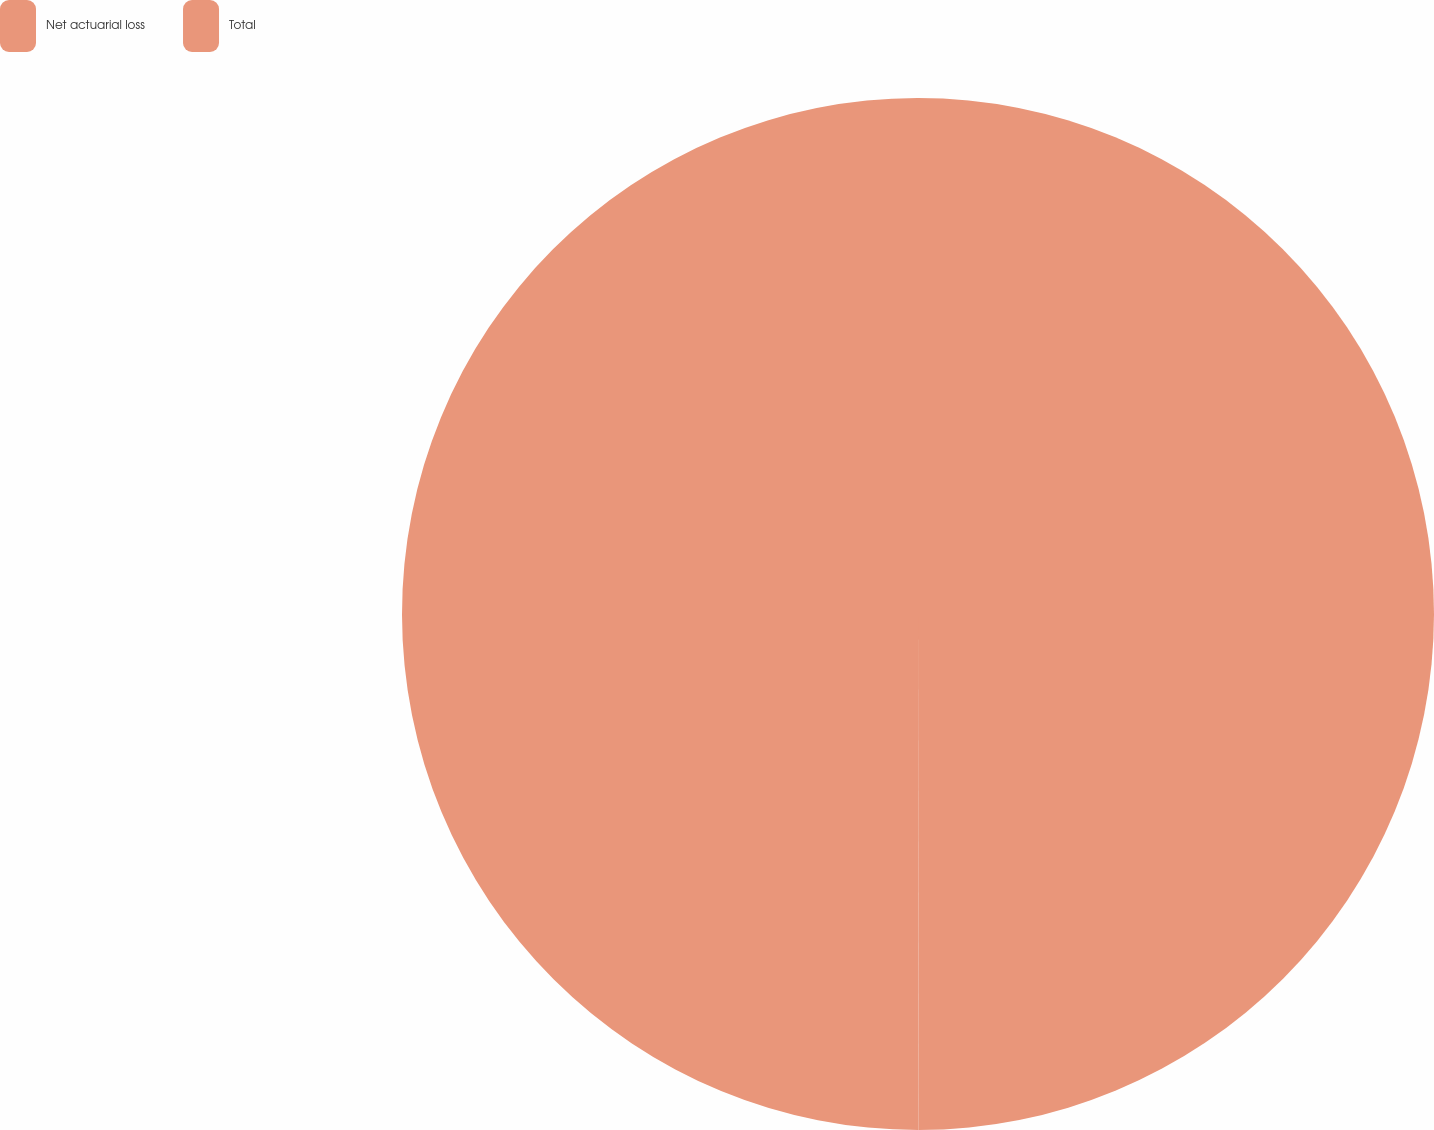Convert chart to OTSL. <chart><loc_0><loc_0><loc_500><loc_500><pie_chart><fcel>Net actuarial loss<fcel>Total<nl><fcel>49.98%<fcel>50.02%<nl></chart> 